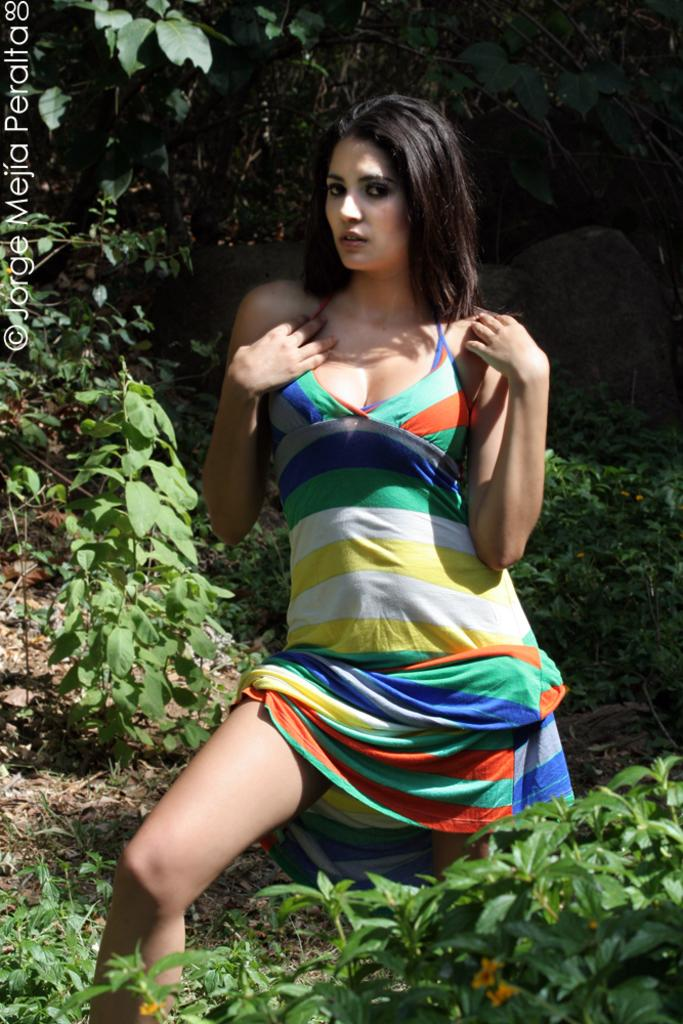What is the main subject of the image? There is a woman standing in the image. What can be seen near the woman? There are plants near the woman. Is there any additional information visible on the image? Yes, there is a watermark on the left side of the image. What type of government is depicted in the image? There is no depiction of a government in the image; it features a woman standing near plants. Can you tell me how many crates are visible in the image? There are no crates present in the image. 